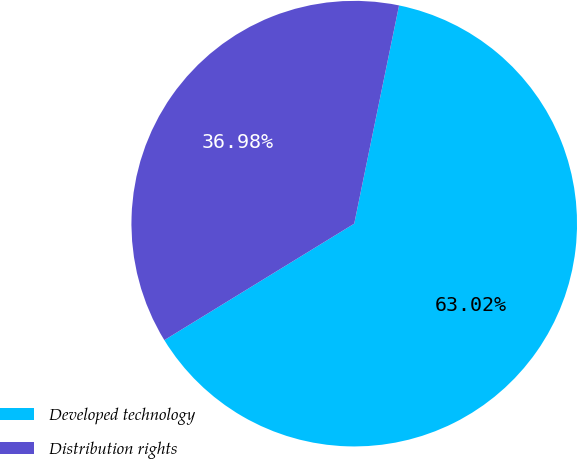Convert chart to OTSL. <chart><loc_0><loc_0><loc_500><loc_500><pie_chart><fcel>Developed technology<fcel>Distribution rights<nl><fcel>63.02%<fcel>36.98%<nl></chart> 